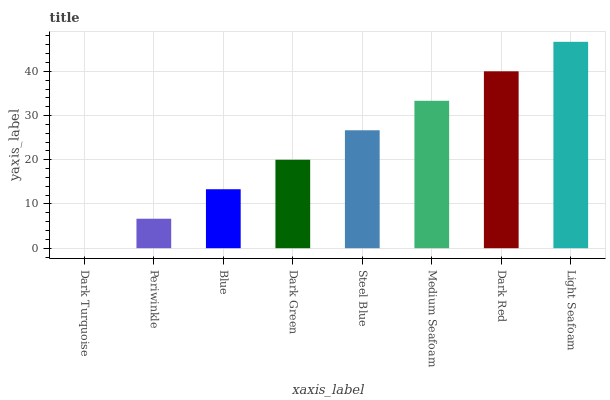Is Dark Turquoise the minimum?
Answer yes or no. Yes. Is Light Seafoam the maximum?
Answer yes or no. Yes. Is Periwinkle the minimum?
Answer yes or no. No. Is Periwinkle the maximum?
Answer yes or no. No. Is Periwinkle greater than Dark Turquoise?
Answer yes or no. Yes. Is Dark Turquoise less than Periwinkle?
Answer yes or no. Yes. Is Dark Turquoise greater than Periwinkle?
Answer yes or no. No. Is Periwinkle less than Dark Turquoise?
Answer yes or no. No. Is Steel Blue the high median?
Answer yes or no. Yes. Is Dark Green the low median?
Answer yes or no. Yes. Is Dark Red the high median?
Answer yes or no. No. Is Blue the low median?
Answer yes or no. No. 